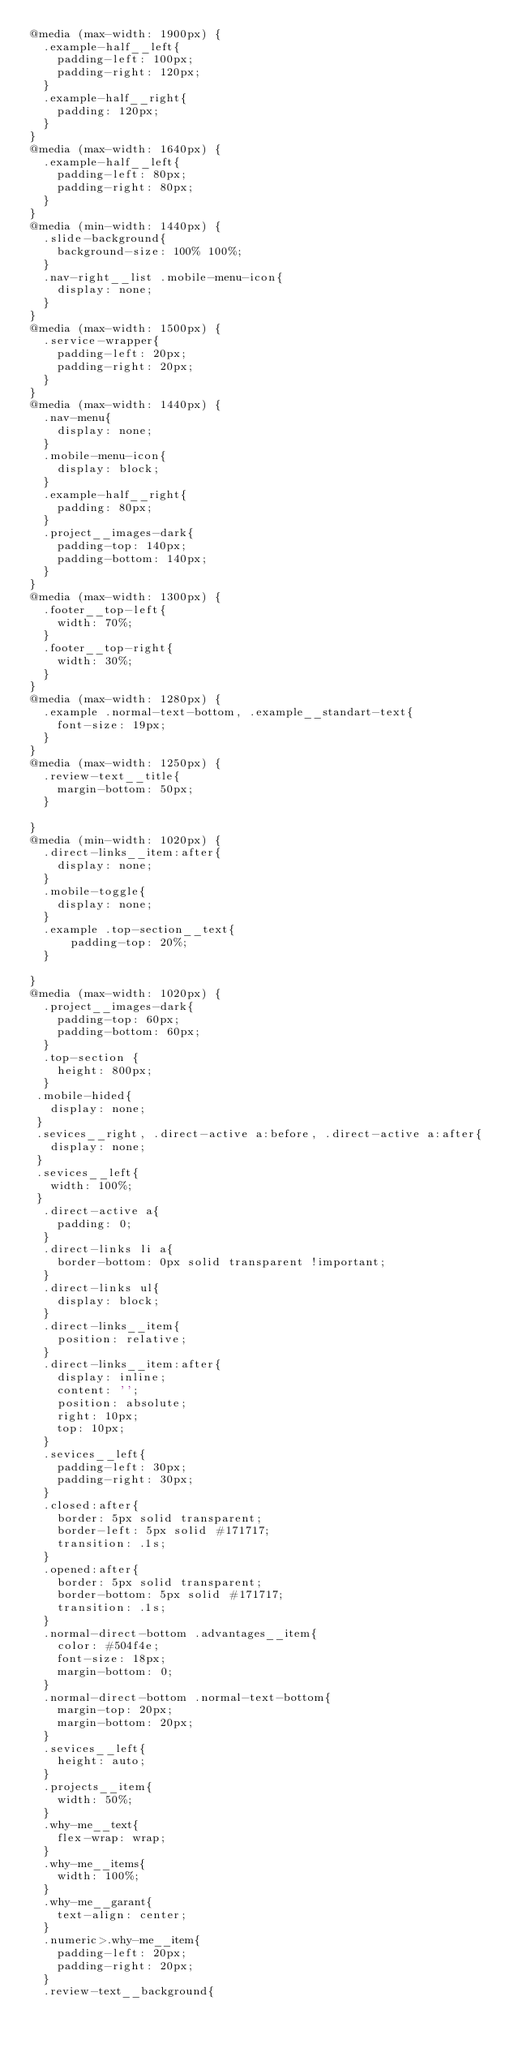Convert code to text. <code><loc_0><loc_0><loc_500><loc_500><_CSS_>@media (max-width: 1900px) {
  .example-half__left{
    padding-left: 100px;
    padding-right: 120px;
  }
  .example-half__right{
    padding: 120px;
  }
}
@media (max-width: 1640px) {
  .example-half__left{
    padding-left: 80px;
    padding-right: 80px;
  }
}
@media (min-width: 1440px) {
  .slide-background{
    background-size: 100% 100%;
  }
  .nav-right__list .mobile-menu-icon{
    display: none;
  }
}
@media (max-width: 1500px) {
  .service-wrapper{
    padding-left: 20px;
    padding-right: 20px;
  }
}
@media (max-width: 1440px) {
  .nav-menu{
    display: none;
  }
  .mobile-menu-icon{
    display: block;
  }
  .example-half__right{
    padding: 80px;
  }
  .project__images-dark{
    padding-top: 140px;
    padding-bottom: 140px;
  }
}
@media (max-width: 1300px) {
  .footer__top-left{
    width: 70%;
  }
  .footer__top-right{
    width: 30%;
  }
}
@media (max-width: 1280px) {
  .example .normal-text-bottom, .example__standart-text{
    font-size: 19px;
  }
}
@media (max-width: 1250px) {
  .review-text__title{
    margin-bottom: 50px;
  }

}
@media (min-width: 1020px) {
  .direct-links__item:after{
    display: none;
  }
  .mobile-toggle{
    display: none;
  }
  .example .top-section__text{
      padding-top: 20%;
  }

}
@media (max-width: 1020px) {
  .project__images-dark{
    padding-top: 60px;
    padding-bottom: 60px;
  }
  .top-section {
    height: 800px;
  }
 .mobile-hided{
   display: none;
 }
 .sevices__right, .direct-active a:before, .direct-active a:after{
   display: none;
 }
 .sevices__left{
   width: 100%;
 }
  .direct-active a{
    padding: 0;
  }
  .direct-links li a{
    border-bottom: 0px solid transparent !important;
  }
  .direct-links ul{
    display: block;
  }
  .direct-links__item{
    position: relative;
  }
  .direct-links__item:after{
    display: inline;
    content: '';
    position: absolute;
    right: 10px;
    top: 10px;
  }
  .sevices__left{
    padding-left: 30px;
    padding-right: 30px;
  }
  .closed:after{
    border: 5px solid transparent;
    border-left: 5px solid #171717;
    transition: .1s;
  }
  .opened:after{
    border: 5px solid transparent;
    border-bottom: 5px solid #171717;
    transition: .1s;
  }
  .normal-direct-bottom .advantages__item{
    color: #504f4e;
    font-size: 18px;
    margin-bottom: 0;
  }
  .normal-direct-bottom .normal-text-bottom{
    margin-top: 20px;
    margin-bottom: 20px;
  }
  .sevices__left{
    height: auto;
  }
  .projects__item{
    width: 50%;
  }
  .why-me__text{
    flex-wrap: wrap;
  }
  .why-me__items{
    width: 100%;
  }
  .why-me__garant{
    text-align: center;
  }
  .numeric>.why-me__item{
    padding-left: 20px;
    padding-right: 20px;
  }
  .review-text__background{</code> 